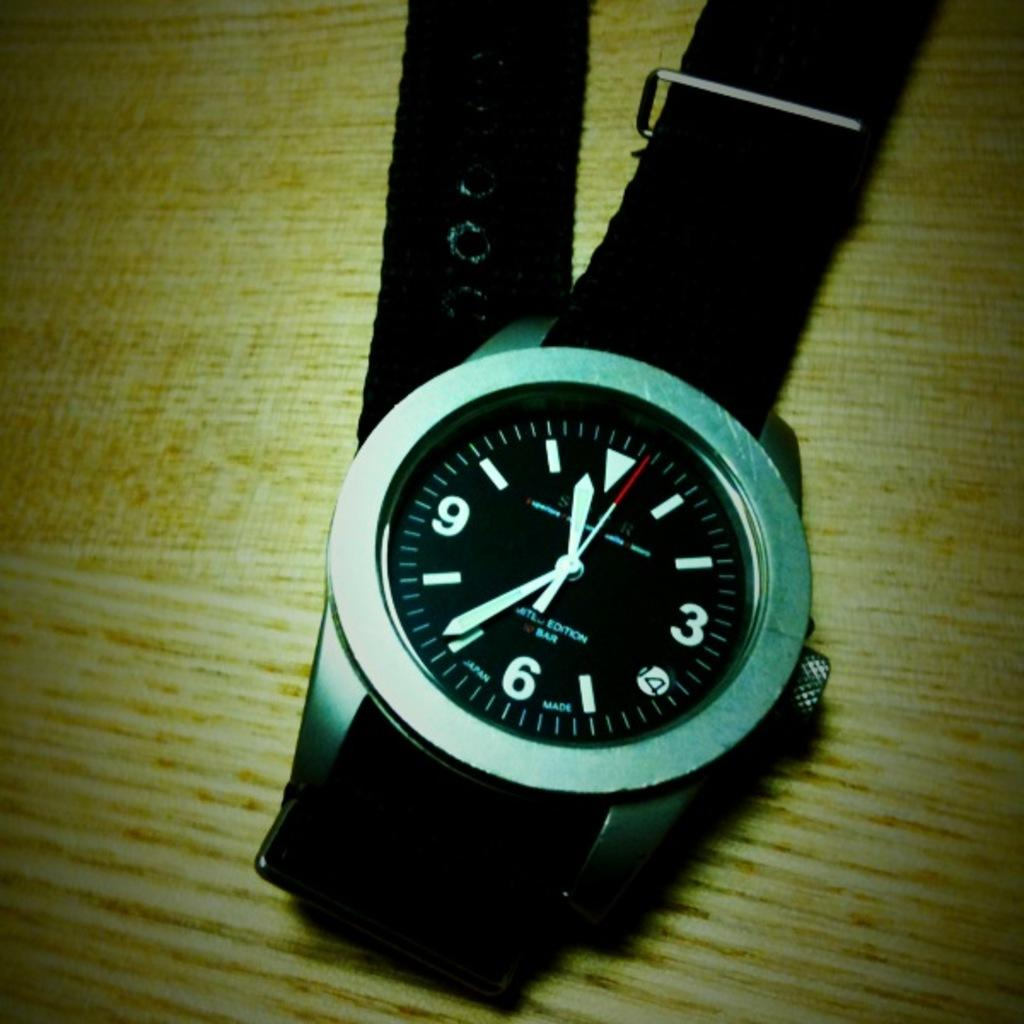<image>
Present a compact description of the photo's key features. A silver Japan made watch with a black band. 